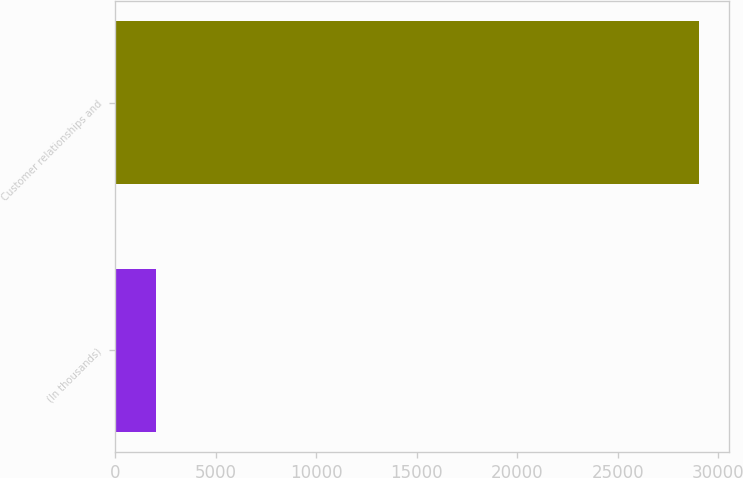Convert chart to OTSL. <chart><loc_0><loc_0><loc_500><loc_500><bar_chart><fcel>(In thousands)<fcel>Customer relationships and<nl><fcel>2013<fcel>29064<nl></chart> 